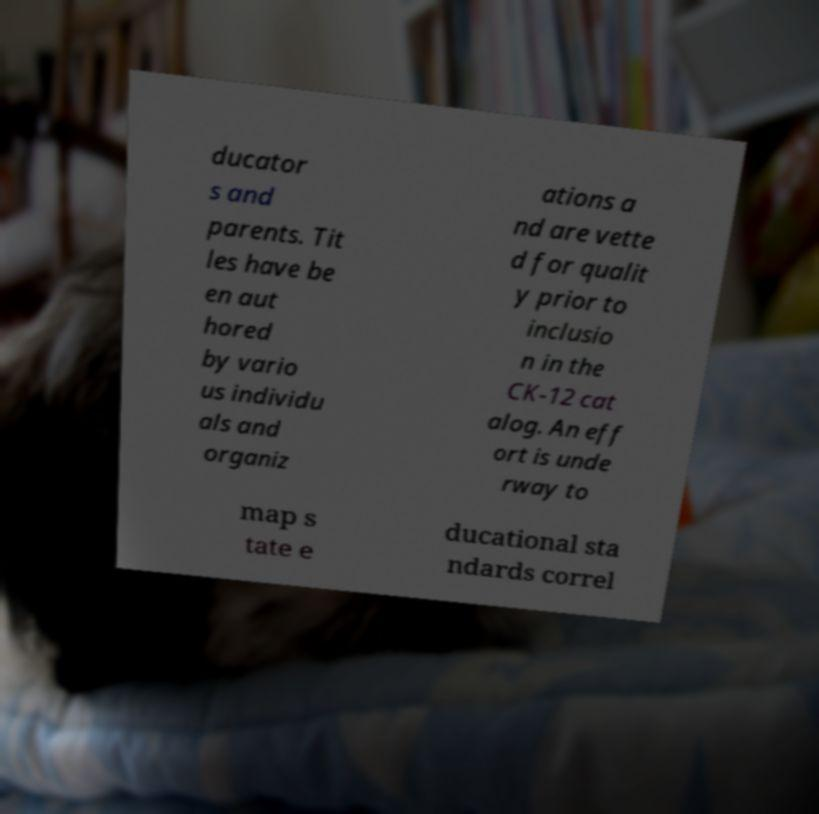For documentation purposes, I need the text within this image transcribed. Could you provide that? ducator s and parents. Tit les have be en aut hored by vario us individu als and organiz ations a nd are vette d for qualit y prior to inclusio n in the CK-12 cat alog. An eff ort is unde rway to map s tate e ducational sta ndards correl 